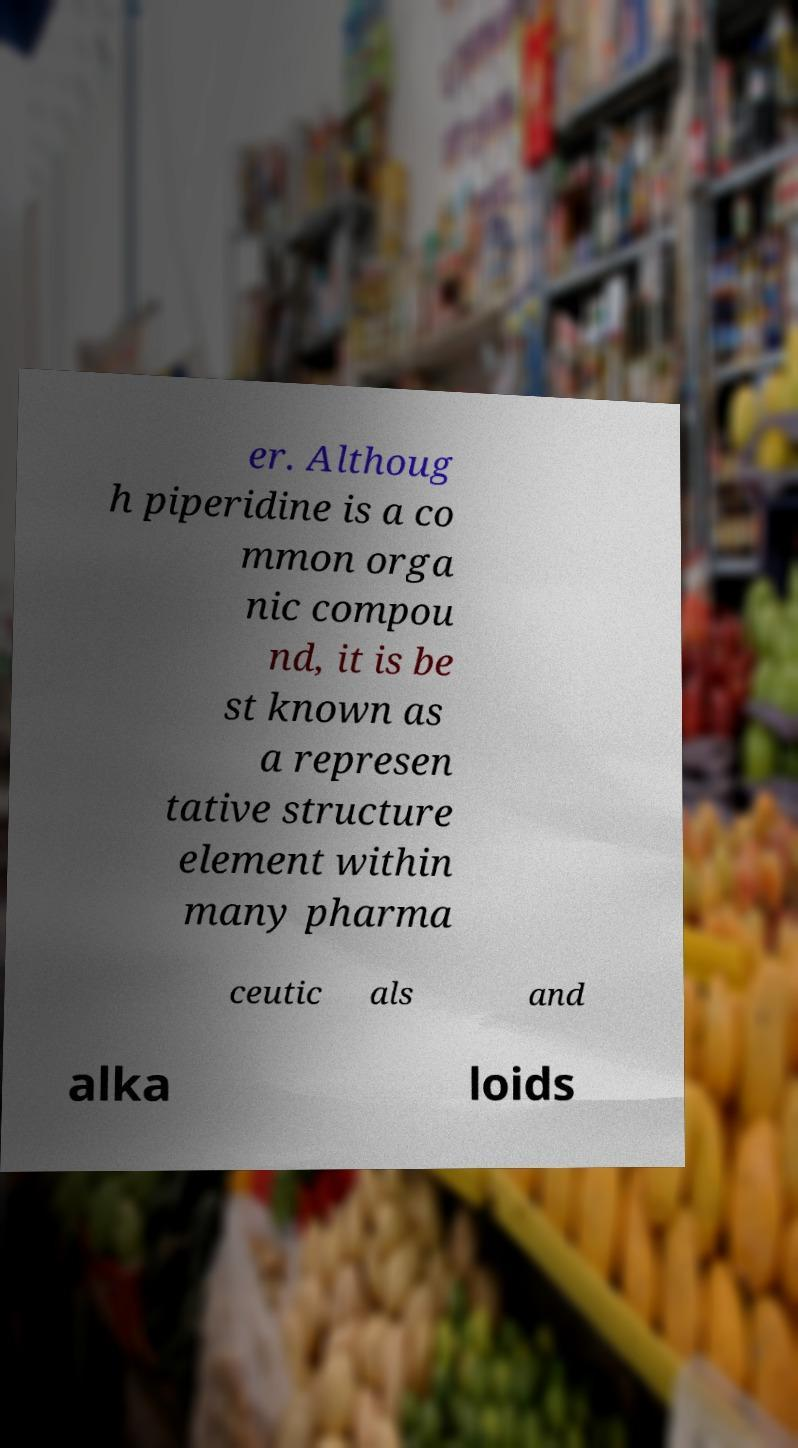For documentation purposes, I need the text within this image transcribed. Could you provide that? er. Althoug h piperidine is a co mmon orga nic compou nd, it is be st known as a represen tative structure element within many pharma ceutic als and alka loids 